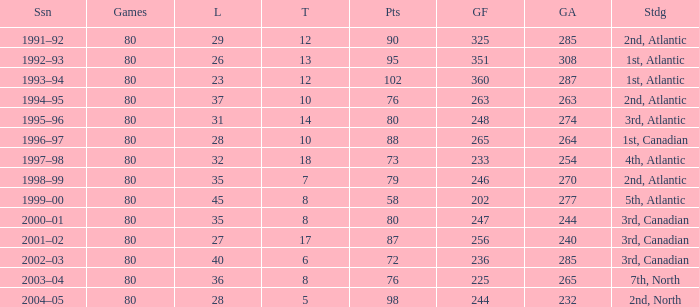How many goals against have 58 points? 277.0. 